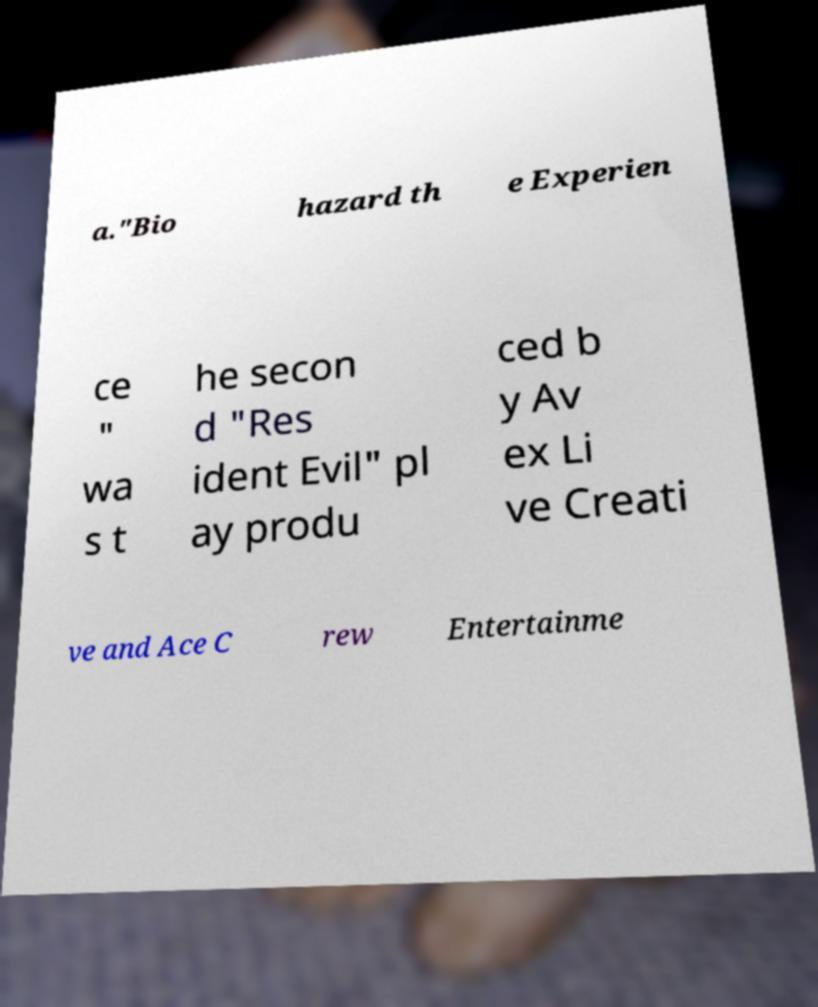Could you extract and type out the text from this image? a."Bio hazard th e Experien ce " wa s t he secon d "Res ident Evil" pl ay produ ced b y Av ex Li ve Creati ve and Ace C rew Entertainme 